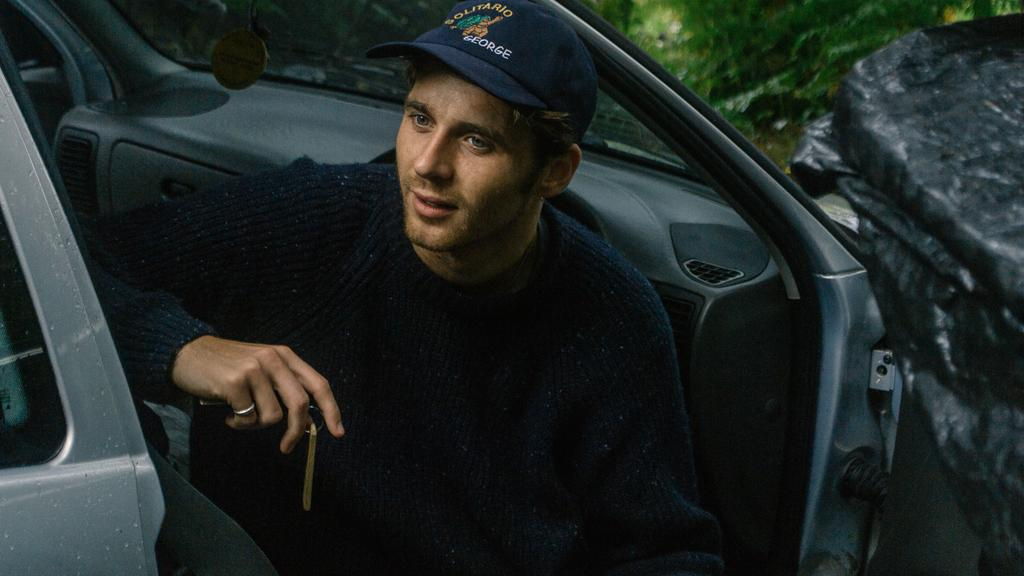What is the person in the car doing? The person is sitting in the car. What object is the person holding? The person is holding keys. What color is the kite that the person is flying in the image? There is no kite present in the image; the person is sitting in a car and holding keys. 